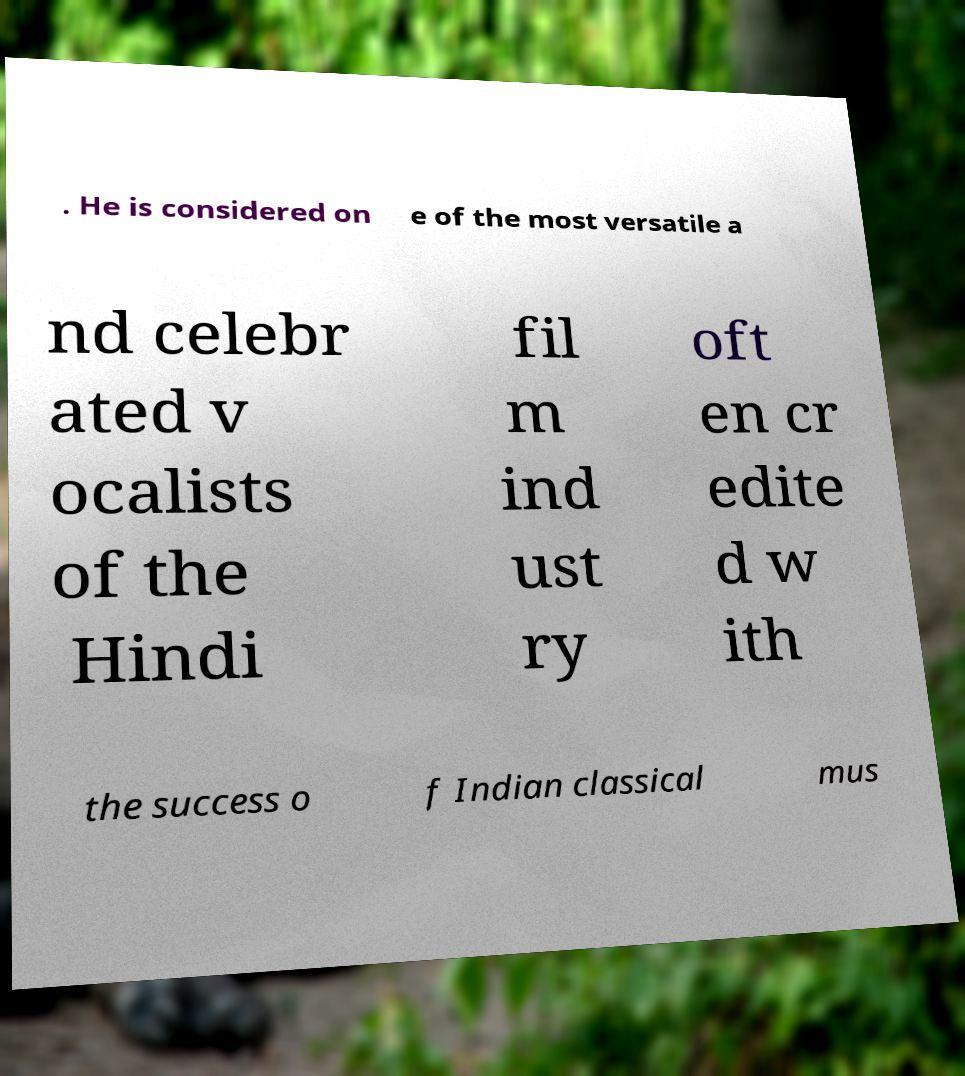Can you accurately transcribe the text from the provided image for me? . He is considered on e of the most versatile a nd celebr ated v ocalists of the Hindi fil m ind ust ry oft en cr edite d w ith the success o f Indian classical mus 